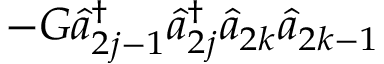<formula> <loc_0><loc_0><loc_500><loc_500>- G \hat { a } _ { 2 j - 1 } ^ { \dagger } \hat { a } _ { 2 j } ^ { \dagger } \hat { a } _ { 2 k } \hat { a } _ { 2 k - 1 }</formula> 